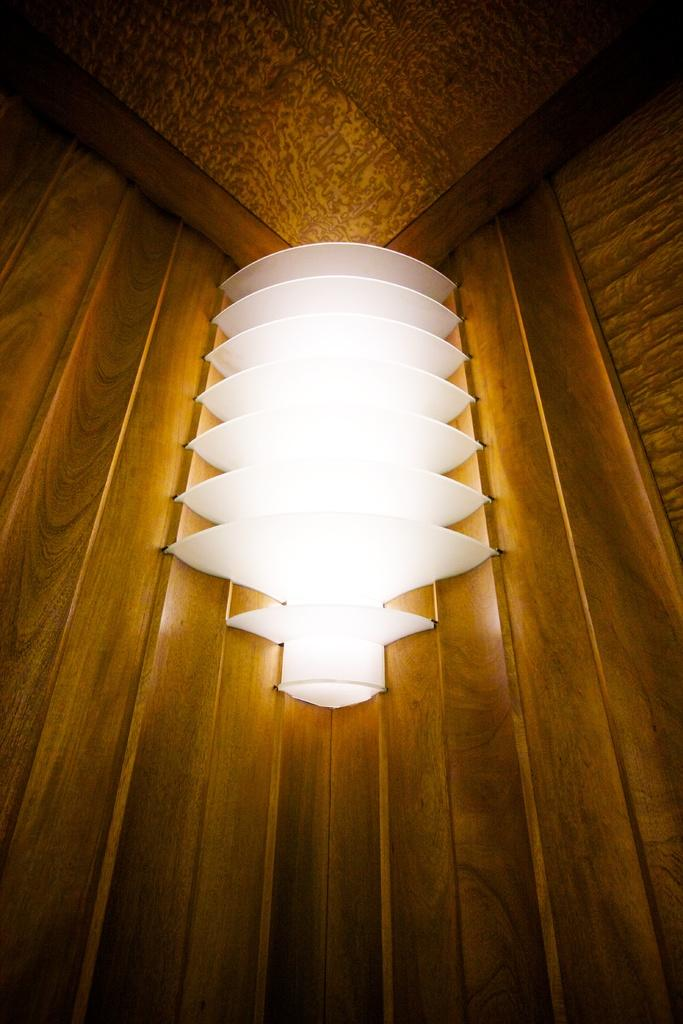What type of material is used for the wall in the image? There is a wooden wall in the image. What kind of lighting is present in the image? There is a decorative light in the image. How many women are present in the image? There is no woman present in the image; it only features a wooden wall and a decorative light. What type of dust can be seen on the wooden wall in the image? There is no dust visible on the wooden wall in the image. 